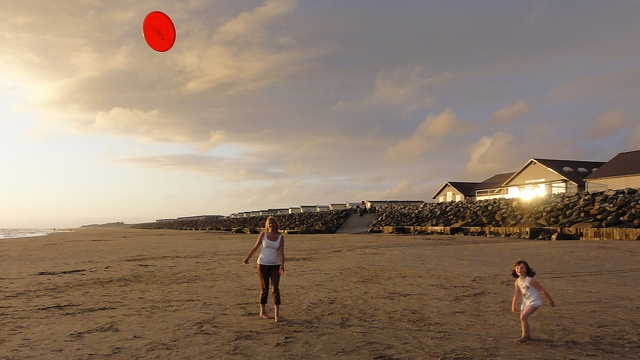Describe the objects in this image and their specific colors. I can see people in tan, black, maroon, and gray tones, people in tan, maroon, gray, and black tones, frisbee in tan, red, and brown tones, people in tan, black, and gray tones, and people in tan, black, maroon, brown, and gray tones in this image. 